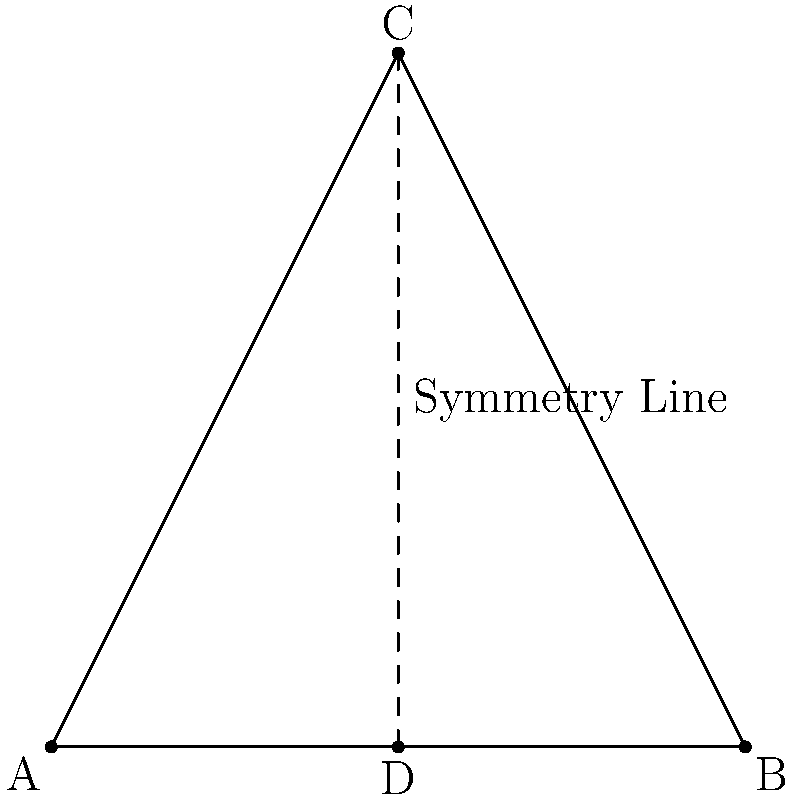In jewelry design, symmetry often plays a crucial role. Consider the triangular pendant design shown above. If point D is the midpoint of side AB, and CD is a line of symmetry for the triangle, what is the ratio of the area of triangle ACD to the area of the entire triangle ABC? Let's approach this step-by-step:

1) In a triangle, a line from a vertex to the midpoint of the opposite side divides the triangle into two equal areas. This is known as the median property.

2) Here, CD is not just a median but also a line of symmetry. This means it's perpendicular to AB.

3) When a median is perpendicular to its base, it's also the altitude and the angle bisector. This makes the triangle isosceles.

4) In an isosceles triangle with a line of symmetry, the two parts created by the line of symmetry are congruent.

5) Therefore, triangle ACD is congruent to triangle BCD.

6) If two triangles are congruent, they have equal areas.

7) Since triangle ACD and triangle BCD are congruent, they each represent half of the total area of triangle ABC.

8) Thus, the area of triangle ACD is $\frac{1}{2}$ of the area of triangle ABC.

9) We can express this as a ratio: $\frac{\text{Area of ACD}}{\text{Area of ABC}} = \frac{1}{2}$
Answer: $\frac{1}{2}$ or 1:2 